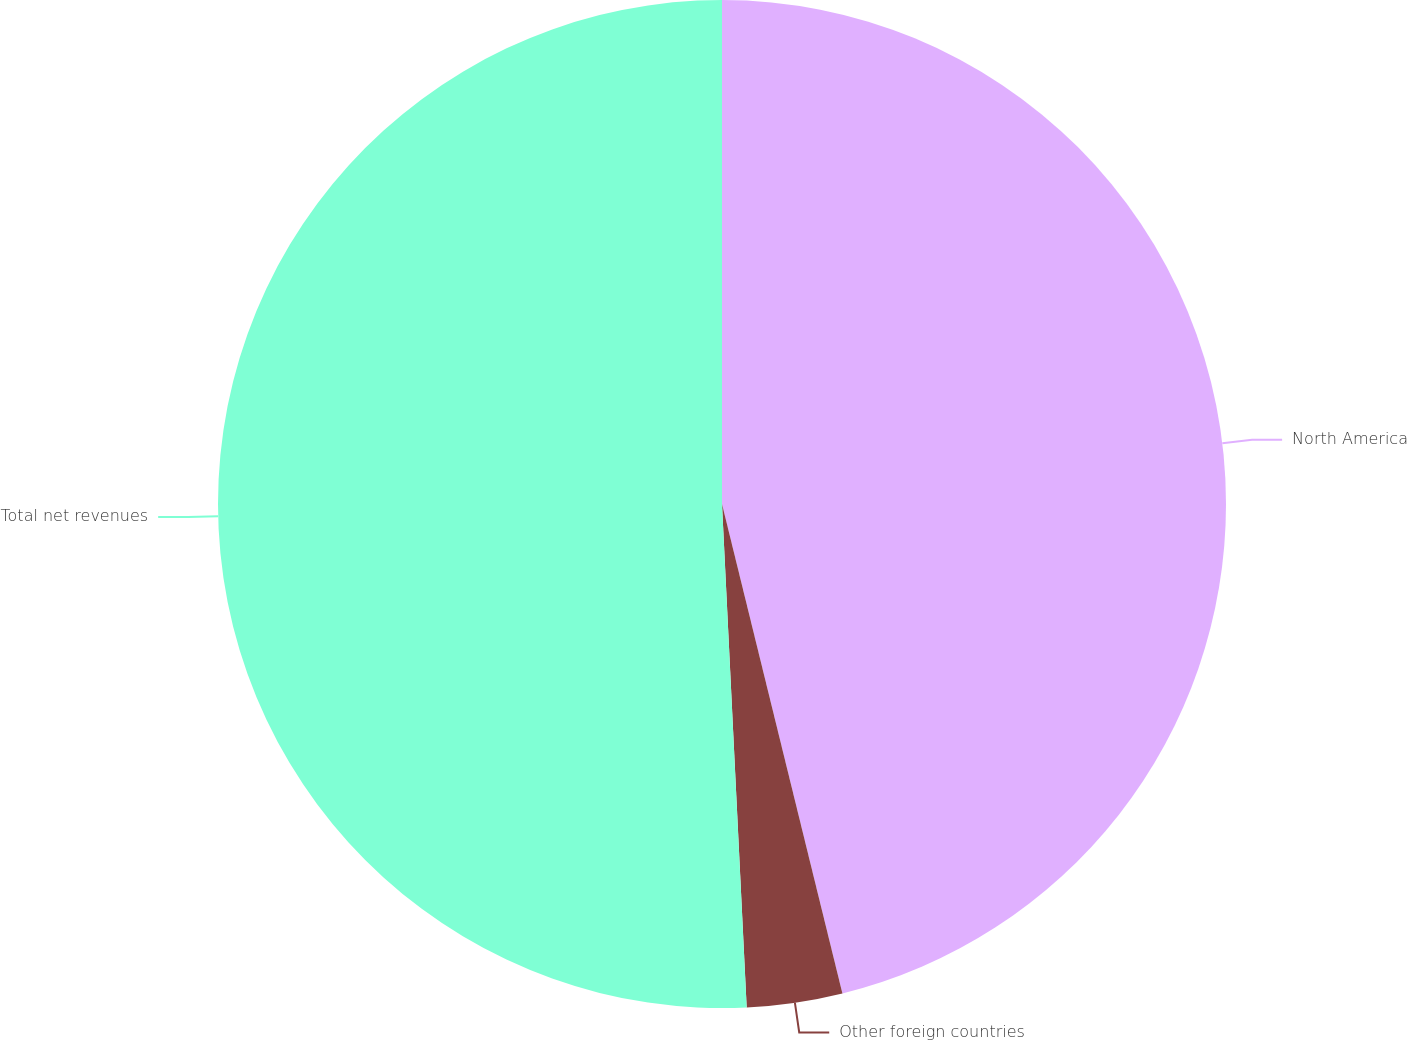Convert chart to OTSL. <chart><loc_0><loc_0><loc_500><loc_500><pie_chart><fcel>North America<fcel>Other foreign countries<fcel>Total net revenues<nl><fcel>46.16%<fcel>3.06%<fcel>50.78%<nl></chart> 